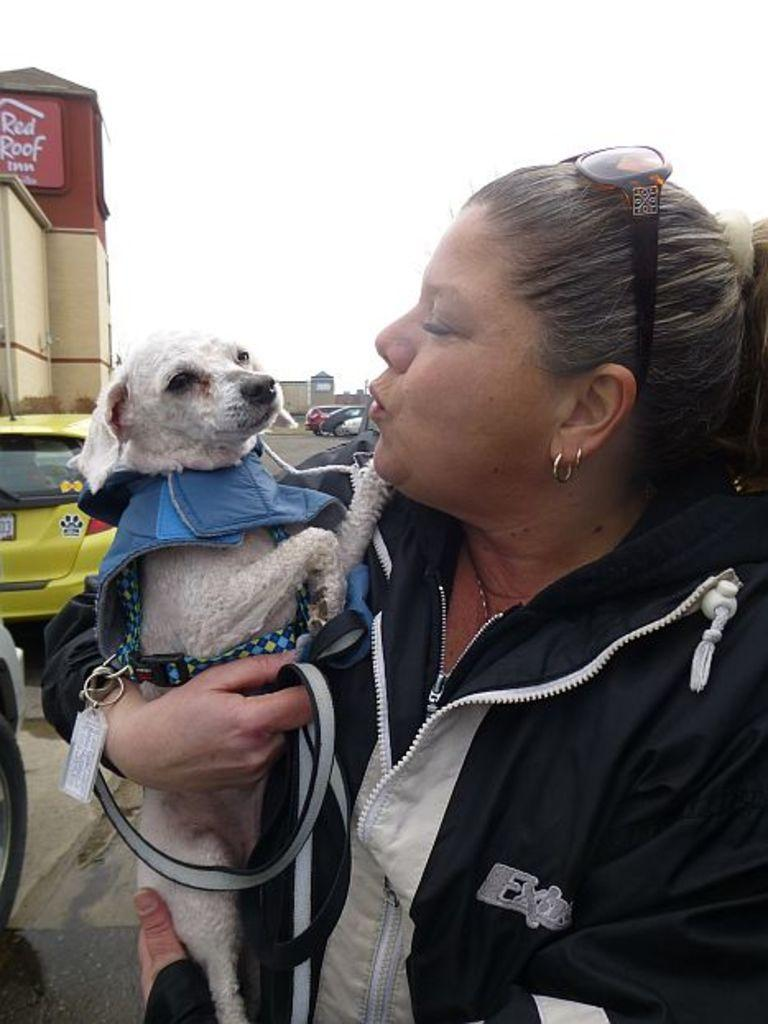What is the lady in the image doing? The lady is standing in the image and holding a dog. What else can be seen in the background of the image? There are cars on the road and buildings in the background of the image. What is visible at the top of the image? The sky is visible at the top of the image. Where is the hydrant located in the image? There is no hydrant present in the image. What type of laborer can be seen working in the background of the image? There are no laborers present in the image. 